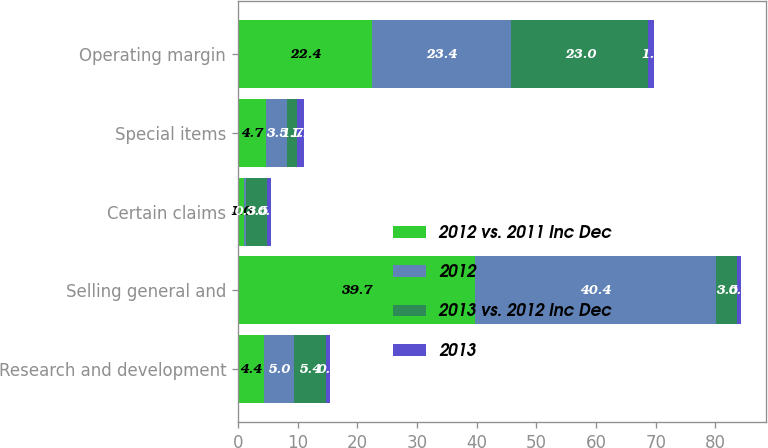<chart> <loc_0><loc_0><loc_500><loc_500><stacked_bar_chart><ecel><fcel>Research and development<fcel>Selling general and<fcel>Certain claims<fcel>Special items<fcel>Operating margin<nl><fcel>2012 vs. 2011 Inc Dec<fcel>4.4<fcel>39.7<fcel>1<fcel>4.7<fcel>22.4<nl><fcel>2012<fcel>5<fcel>40.4<fcel>0.3<fcel>3.5<fcel>23.4<nl><fcel>2013 vs. 2012 Inc Dec<fcel>5.4<fcel>3.5<fcel>3.5<fcel>1.7<fcel>23<nl><fcel>2013<fcel>0.6<fcel>0.7<fcel>0.7<fcel>1.2<fcel>1<nl></chart> 